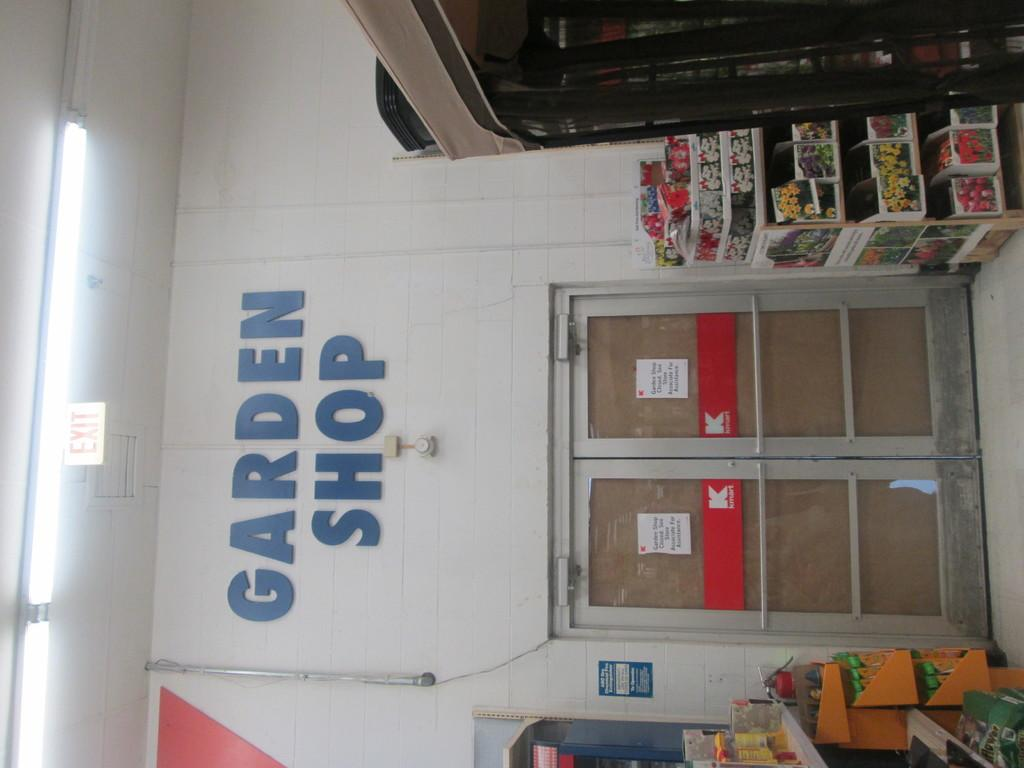Provide a one-sentence caption for the provided image. two double doors to a k mart with the logo garden shop on top of the doors. 